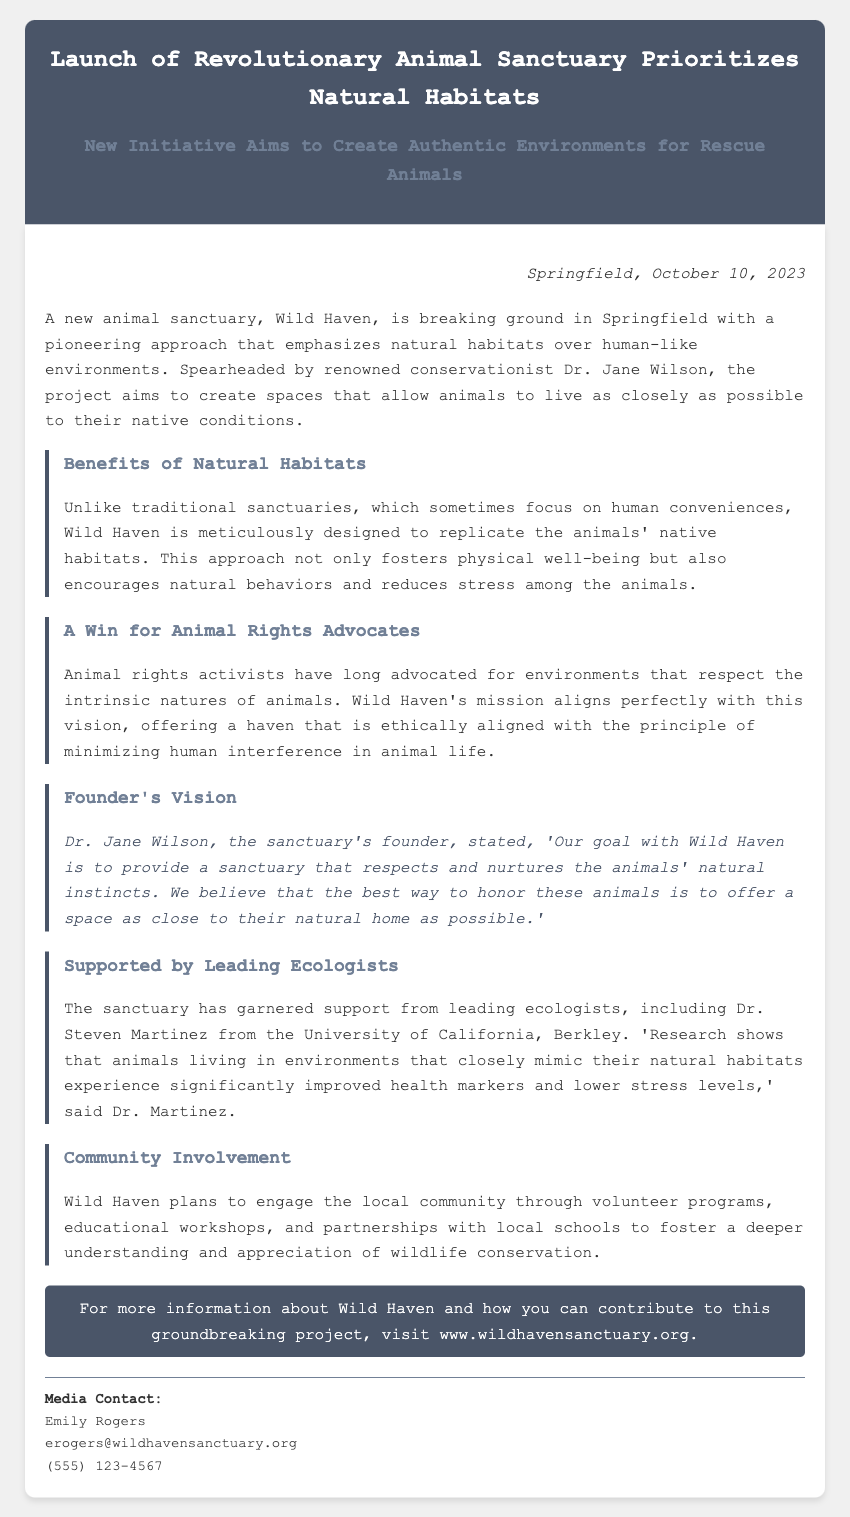What is the name of the sanctuary? The sanctuary is referred to as Wild Haven in the document.
Answer: Wild Haven Who is the founder of the sanctuary? The document states that the founder of the sanctuary is Dr. Jane Wilson.
Answer: Dr. Jane Wilson What date was the press release published? The dateline mentions that the press release was published on October 10, 2023.
Answer: October 10, 2023 What is the primary focus of Wild Haven? The document indicates that the primary focus of Wild Haven is to emphasize natural habitats over human-like environments.
Answer: Natural habitats Which ecologist supports the sanctuary? The document names Dr. Steven Martinez as a supporter of the sanctuary.
Answer: Dr. Steven Martinez What kind of community programs will Wild Haven engage in? The document notes that Wild Haven plans to engage in volunteer programs and educational workshops.
Answer: Volunteer programs and educational workshops What is one benefit mentioned about animals in natural habitats? The document states that animals in environments mimicking their natural habitats experience improved health markers.
Answer: Improved health markers What is the overarching principle of Wild Haven's mission? The mission aligns with minimizing human interference in animal life.
Answer: Minimizing human interference 